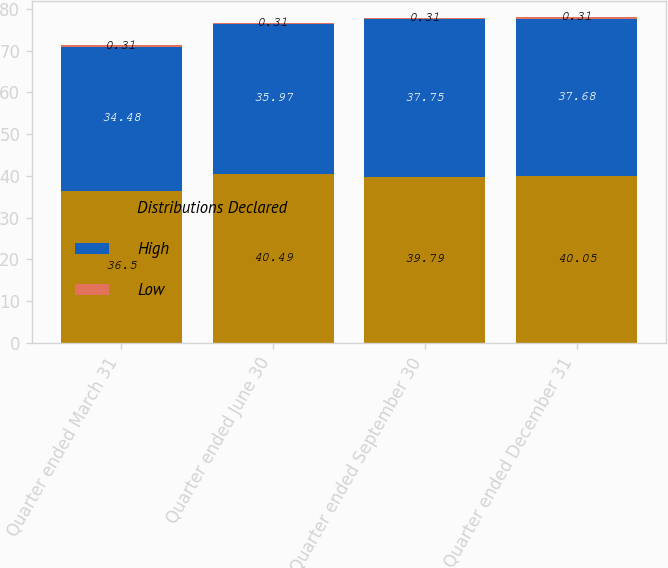Convert chart to OTSL. <chart><loc_0><loc_0><loc_500><loc_500><stacked_bar_chart><ecel><fcel>Quarter ended March 31<fcel>Quarter ended June 30<fcel>Quarter ended September 30<fcel>Quarter ended December 31<nl><fcel>Distributions Declared<fcel>36.5<fcel>40.49<fcel>39.79<fcel>40.05<nl><fcel>High<fcel>34.48<fcel>35.97<fcel>37.75<fcel>37.68<nl><fcel>Low<fcel>0.31<fcel>0.31<fcel>0.31<fcel>0.31<nl></chart> 